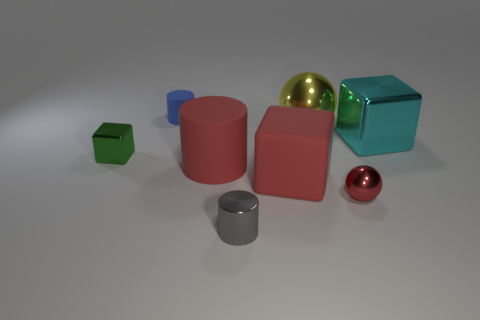Subtract all big rubber blocks. How many blocks are left? 2 Add 2 large yellow things. How many objects exist? 10 Subtract 0 blue cubes. How many objects are left? 8 Subtract all blocks. How many objects are left? 5 Subtract all rubber cylinders. Subtract all metallic objects. How many objects are left? 1 Add 3 cyan metal objects. How many cyan metal objects are left? 4 Add 3 large red rubber objects. How many large red rubber objects exist? 5 